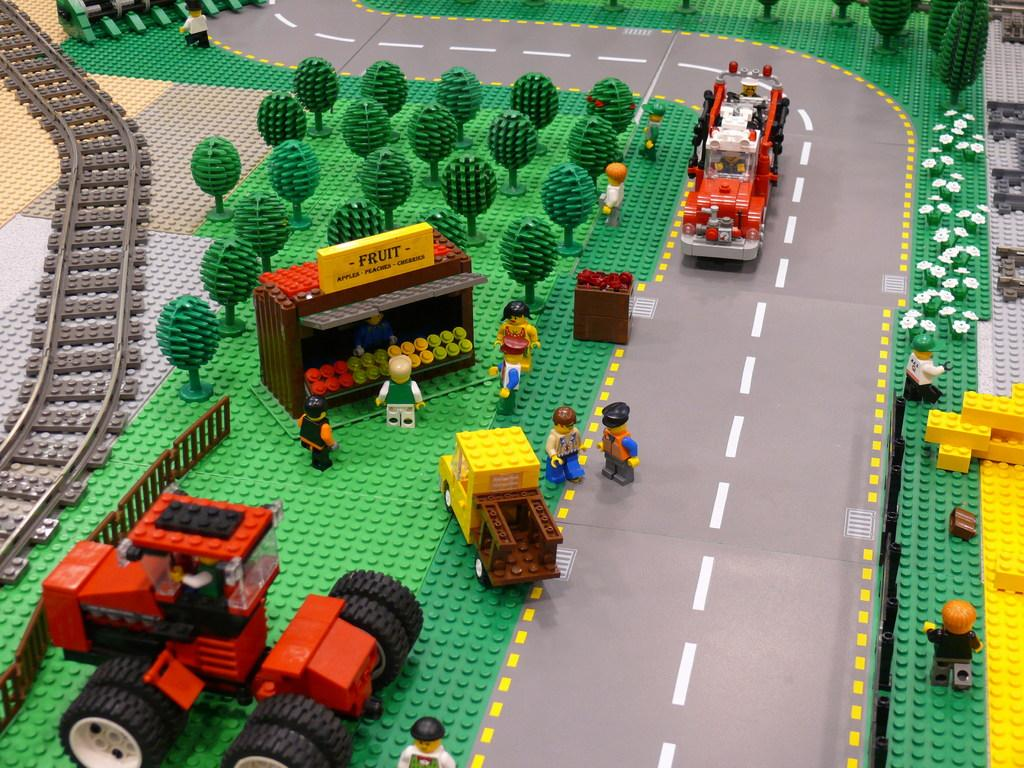<image>
Present a compact description of the photo's key features. A town made of legos features a Fruit stand that sells apples an peaches. 